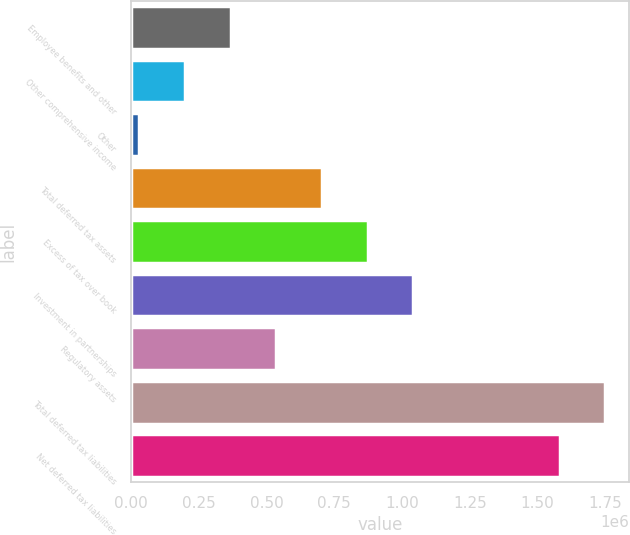Convert chart. <chart><loc_0><loc_0><loc_500><loc_500><bar_chart><fcel>Employee benefits and other<fcel>Other comprehensive income<fcel>Other<fcel>Total deferred tax assets<fcel>Excess of tax over book<fcel>Investment in partnerships<fcel>Regulatory assets<fcel>Total deferred tax liabilities<fcel>Net deferred tax liabilities<nl><fcel>368402<fcel>199973<fcel>31544<fcel>705260<fcel>873688<fcel>1.04212e+06<fcel>536831<fcel>1.75011e+06<fcel>1.58168e+06<nl></chart> 